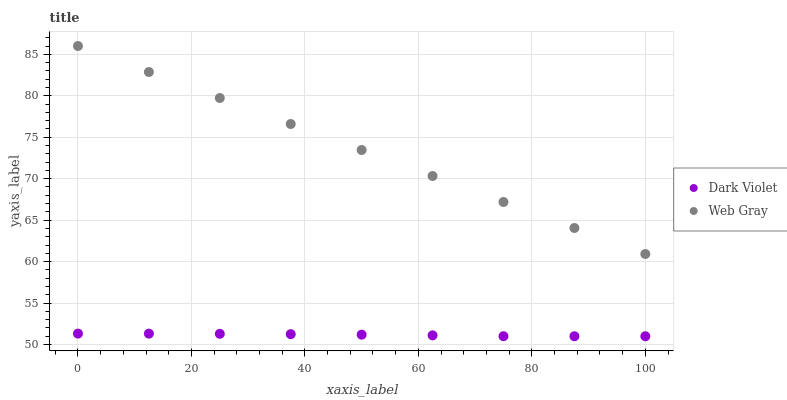Does Dark Violet have the minimum area under the curve?
Answer yes or no. Yes. Does Web Gray have the maximum area under the curve?
Answer yes or no. Yes. Does Dark Violet have the maximum area under the curve?
Answer yes or no. No. Is Web Gray the smoothest?
Answer yes or no. Yes. Is Dark Violet the roughest?
Answer yes or no. Yes. Is Dark Violet the smoothest?
Answer yes or no. No. Does Dark Violet have the lowest value?
Answer yes or no. Yes. Does Web Gray have the highest value?
Answer yes or no. Yes. Does Dark Violet have the highest value?
Answer yes or no. No. Is Dark Violet less than Web Gray?
Answer yes or no. Yes. Is Web Gray greater than Dark Violet?
Answer yes or no. Yes. Does Dark Violet intersect Web Gray?
Answer yes or no. No. 